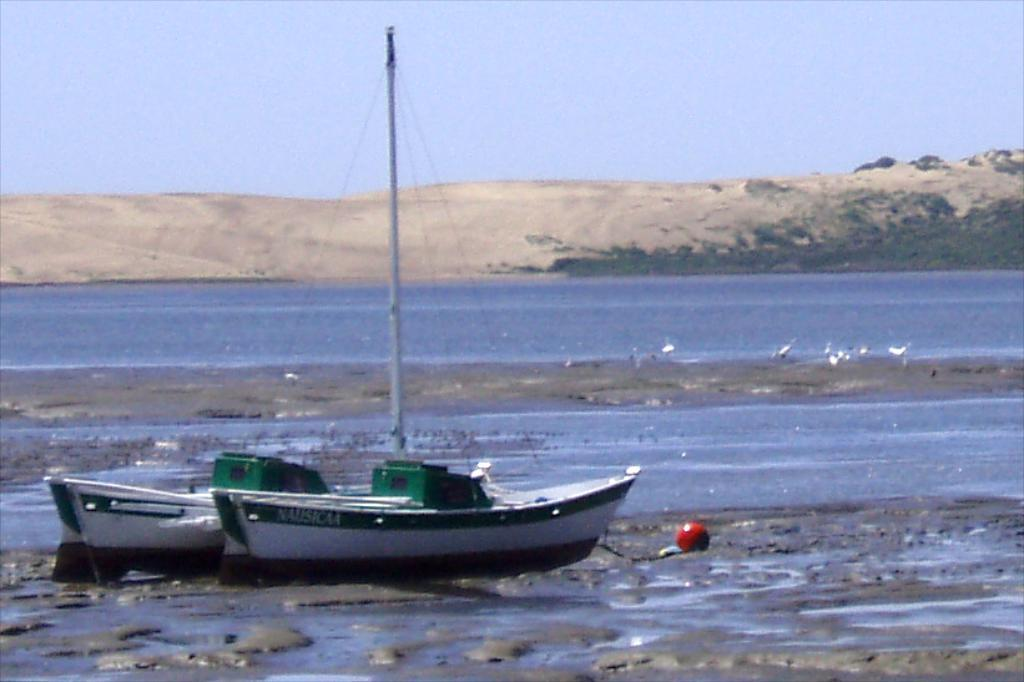What is the primary element in the image? There is water in the image. What is on the water in the image? There is a boat on the water. What type of animals can be seen in the image? There are birds in the image. What can be seen in the background of the image? There are hills and the sky visible in the background of the image. How many sheep are present in the image? There are no sheep present in the image. What force is being applied to the boat in the image? There is no indication of any force being applied to the boat in the image; it appears to be stationary on the water. 